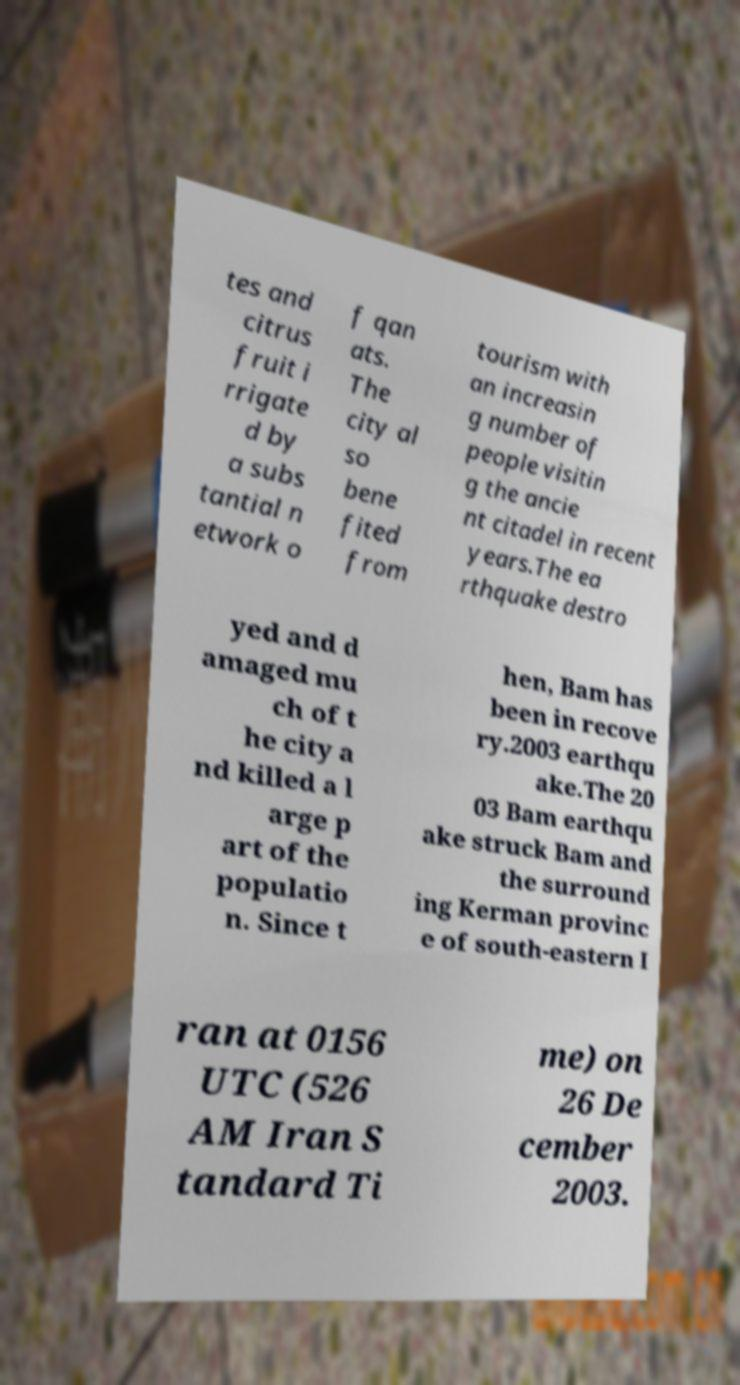Can you accurately transcribe the text from the provided image for me? tes and citrus fruit i rrigate d by a subs tantial n etwork o f qan ats. The city al so bene fited from tourism with an increasin g number of people visitin g the ancie nt citadel in recent years.The ea rthquake destro yed and d amaged mu ch of t he city a nd killed a l arge p art of the populatio n. Since t hen, Bam has been in recove ry.2003 earthqu ake.The 20 03 Bam earthqu ake struck Bam and the surround ing Kerman provinc e of south-eastern I ran at 0156 UTC (526 AM Iran S tandard Ti me) on 26 De cember 2003. 